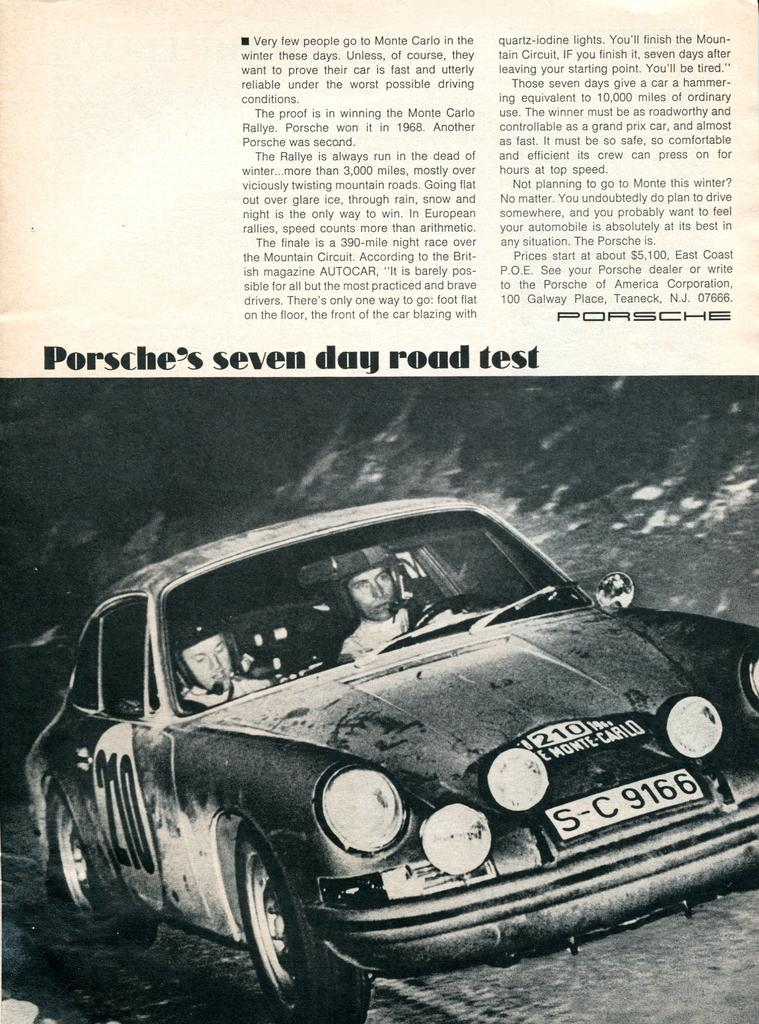What is present in the book in the image? The image contains a paper in a book. What can be found on the paper? There is text on the paper. Is there any illustration on the paper? Yes, there is a picture of a person riding a car on the paper. How many rings are visible on the person riding the car in the image? There are no rings visible on the person riding the car in the image, as the image only shows a picture of a person riding a car with no additional details. 